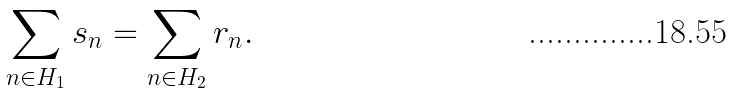<formula> <loc_0><loc_0><loc_500><loc_500>\sum _ { n \in H _ { 1 } } s _ { n } = \sum _ { n \in H _ { 2 } } r _ { n } .</formula> 